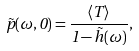<formula> <loc_0><loc_0><loc_500><loc_500>\tilde { p } ( \omega , 0 ) = \frac { \langle T \rangle } { 1 - \tilde { h } ( \omega ) } ,</formula> 